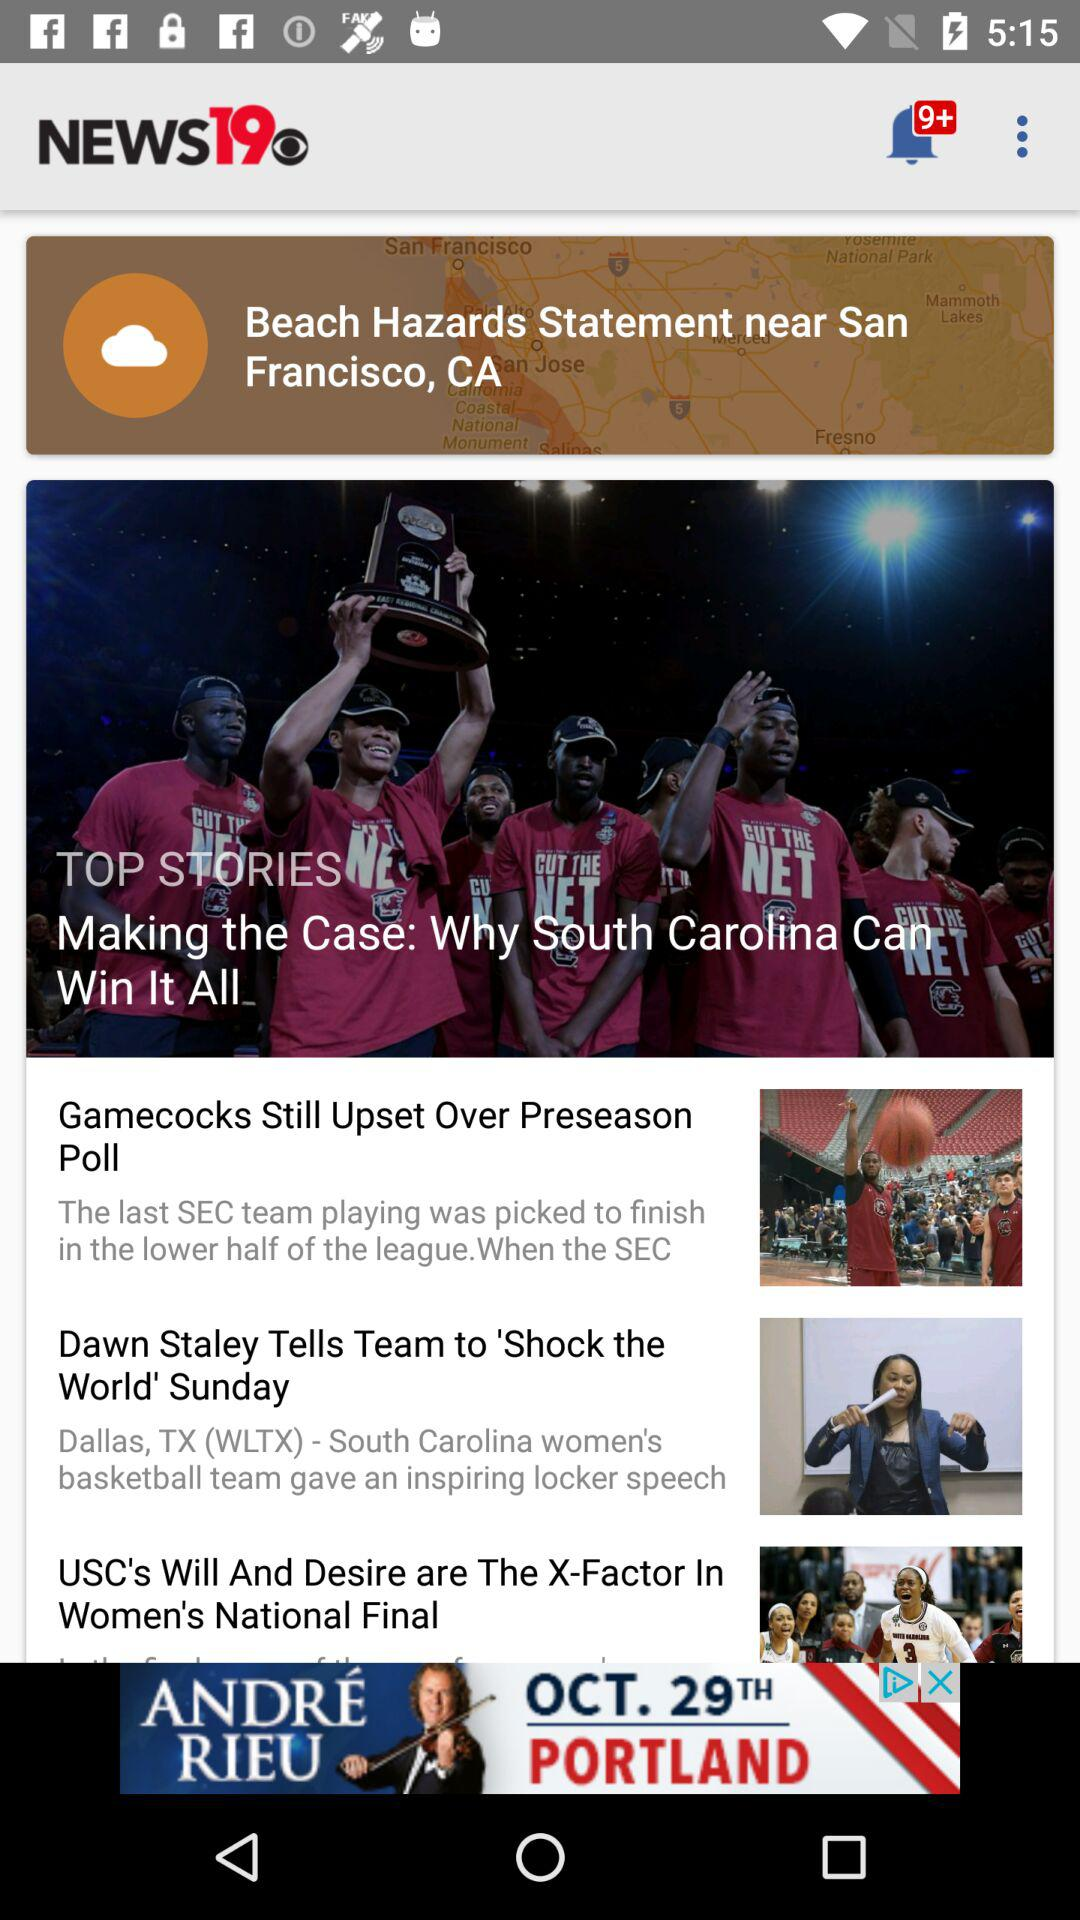What is the headline of the top story? The headlines are "Making the Case: Why South Carolina Can Win It All", "Gamecocks Still Upset Over Preseason Poll", "Dawn Staley Tells Team to 'Shock the World' Sunday" and "USC's Will And Desire are The X-Factor In Women's National Final". 